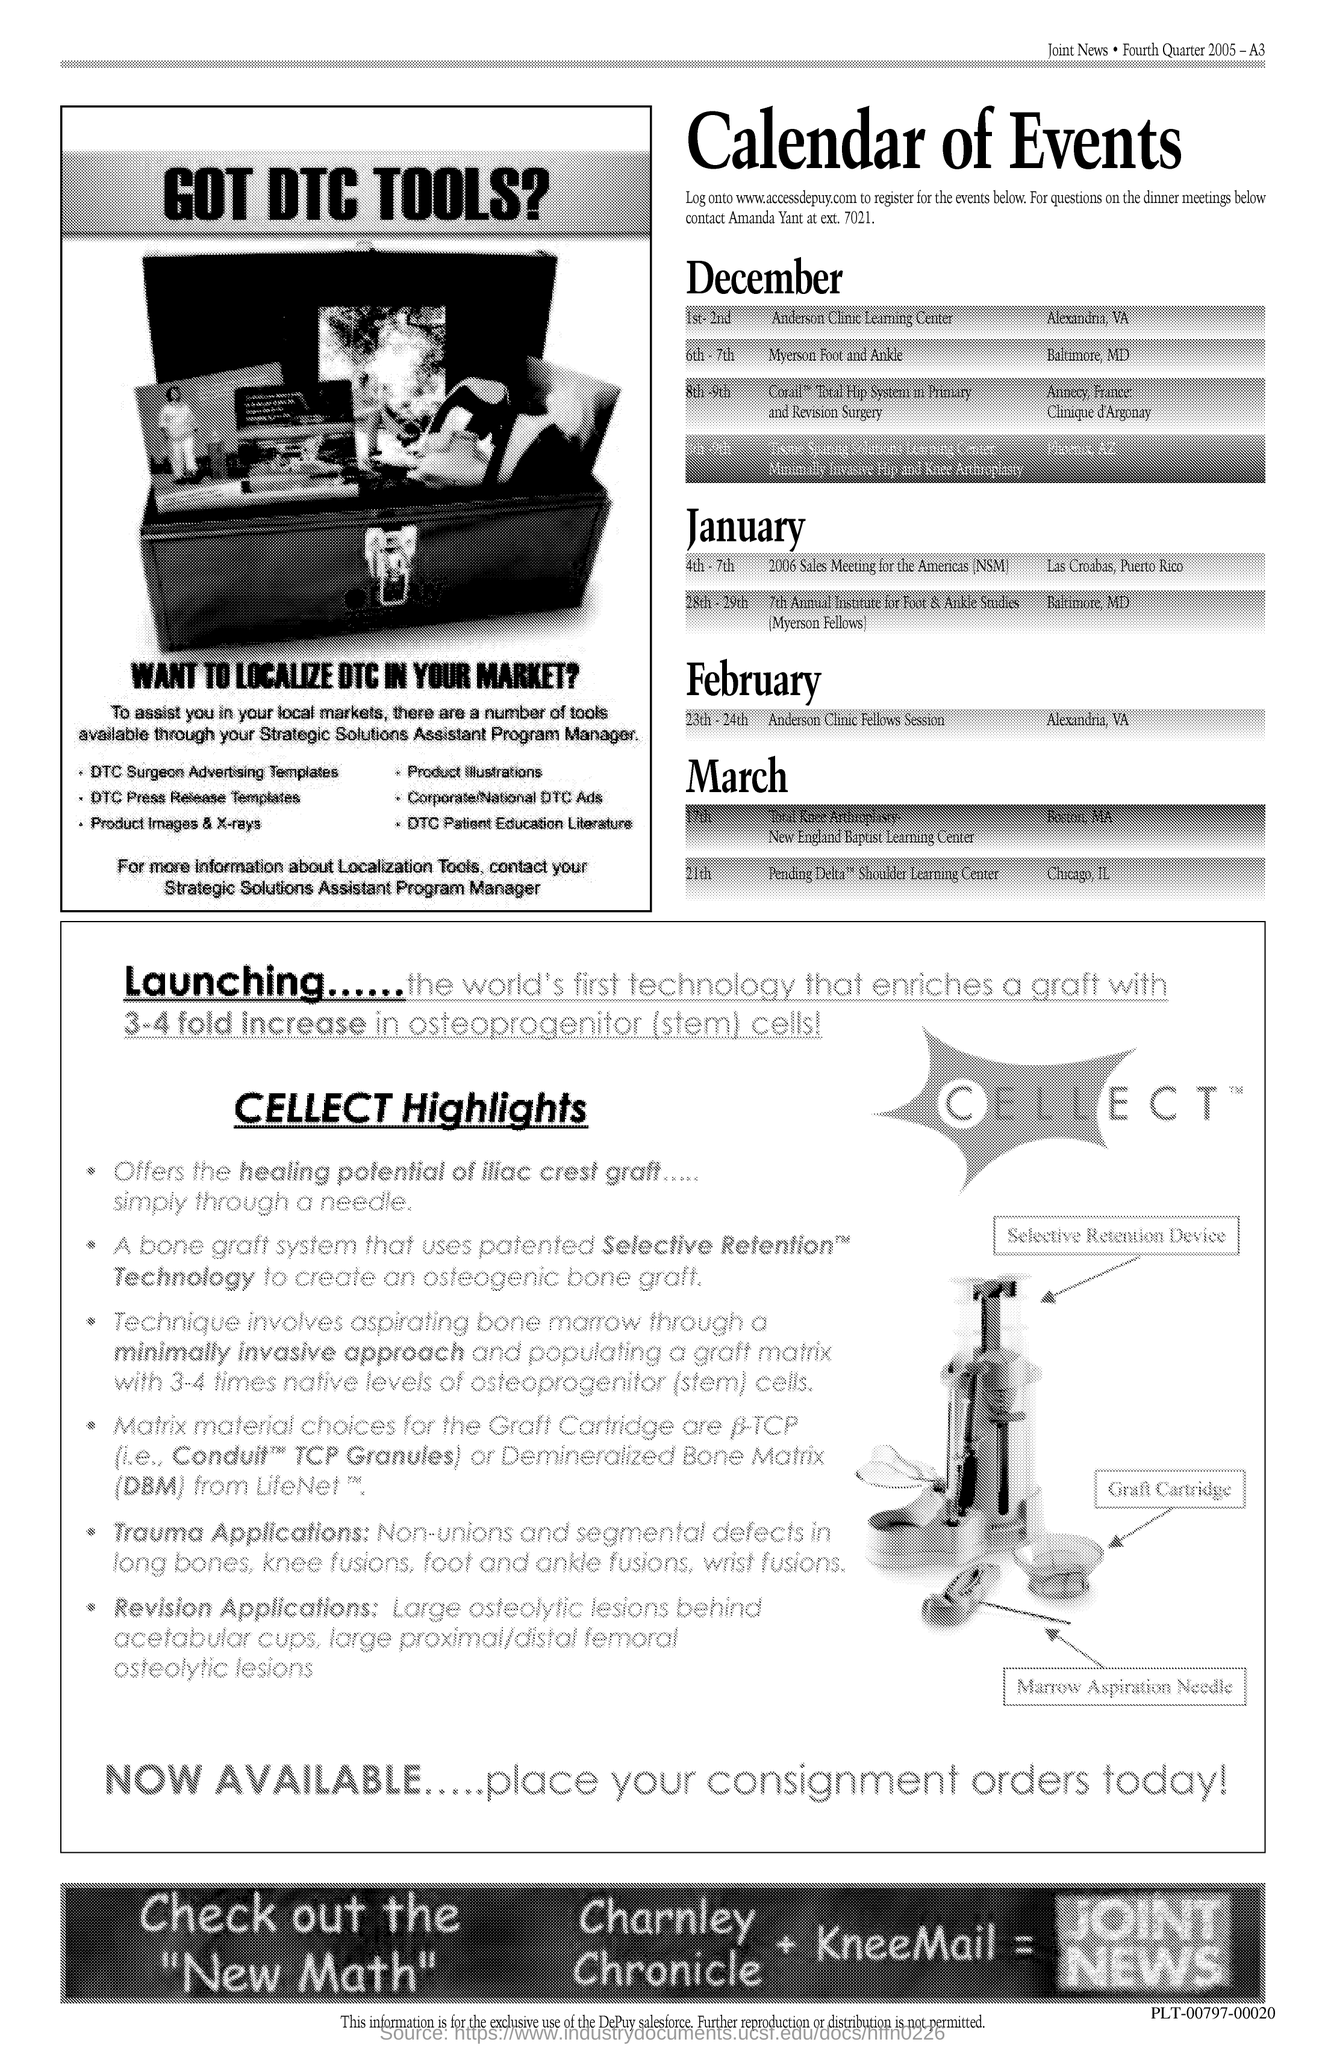Indicate a few pertinent items in this graphic. The title of the document is 'Calendar of Events'. 